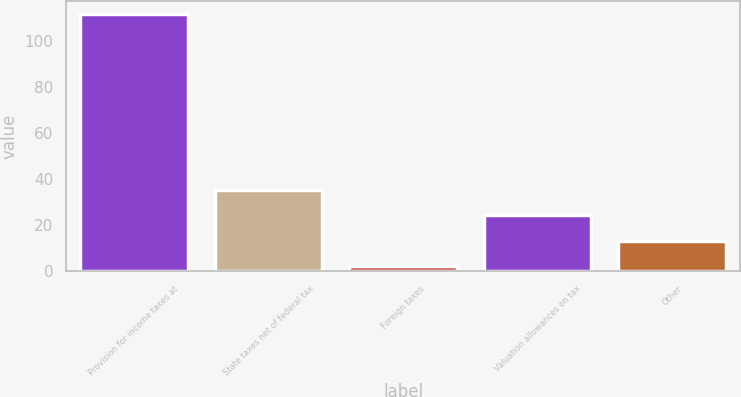<chart> <loc_0><loc_0><loc_500><loc_500><bar_chart><fcel>Provision for income taxes at<fcel>State taxes net of federal tax<fcel>Foreign taxes<fcel>Valuation allowances on tax<fcel>Other<nl><fcel>111.9<fcel>35.18<fcel>2.3<fcel>24.22<fcel>13.26<nl></chart> 